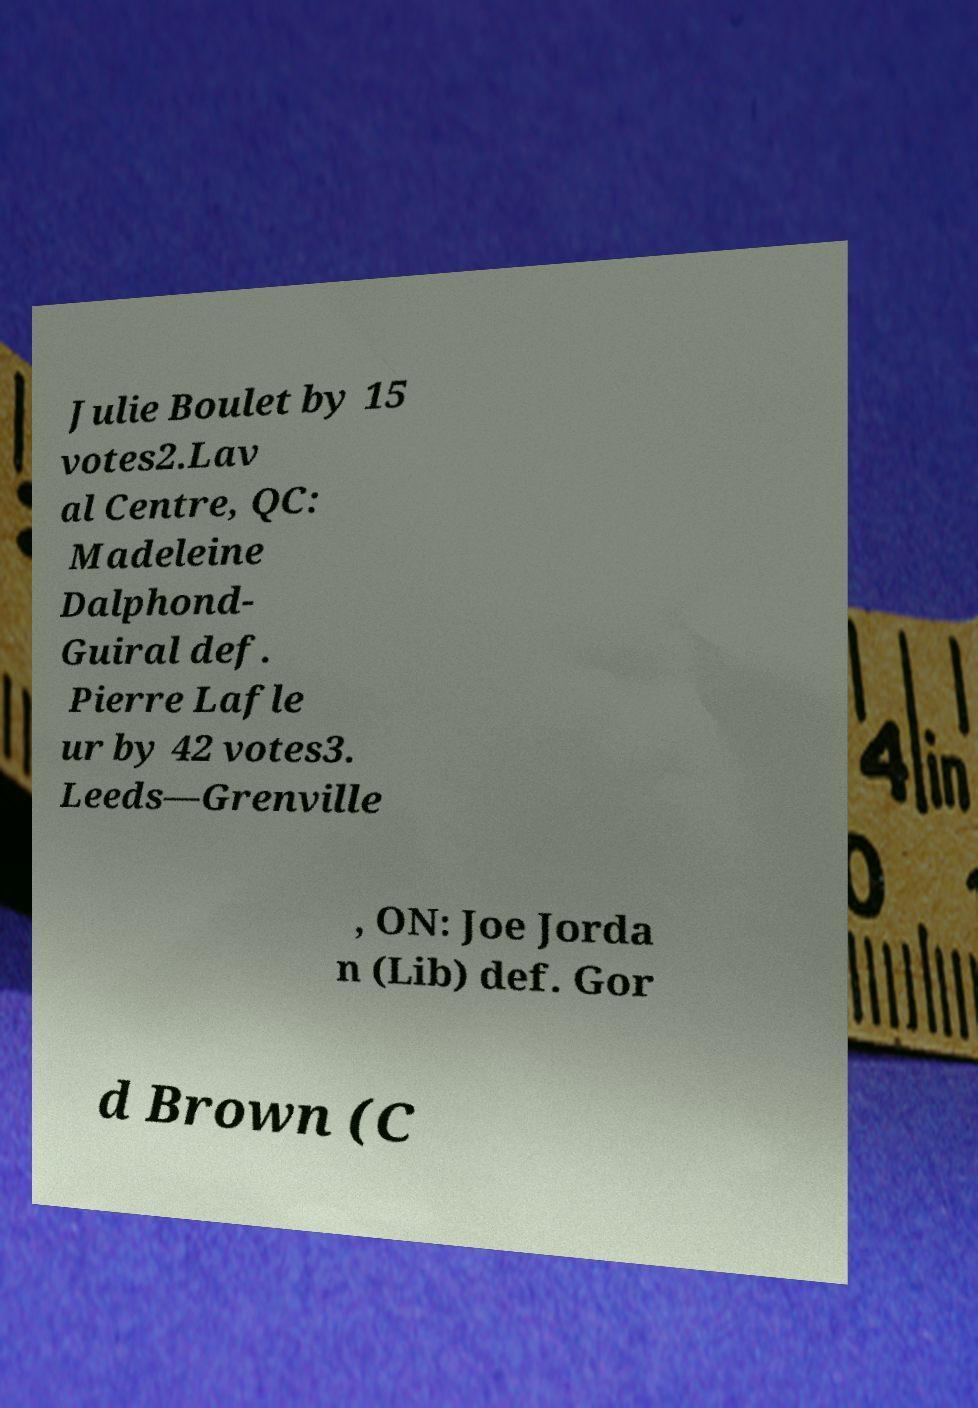Please read and relay the text visible in this image. What does it say? Julie Boulet by 15 votes2.Lav al Centre, QC: Madeleine Dalphond- Guiral def. Pierre Lafle ur by 42 votes3. Leeds—Grenville , ON: Joe Jorda n (Lib) def. Gor d Brown (C 